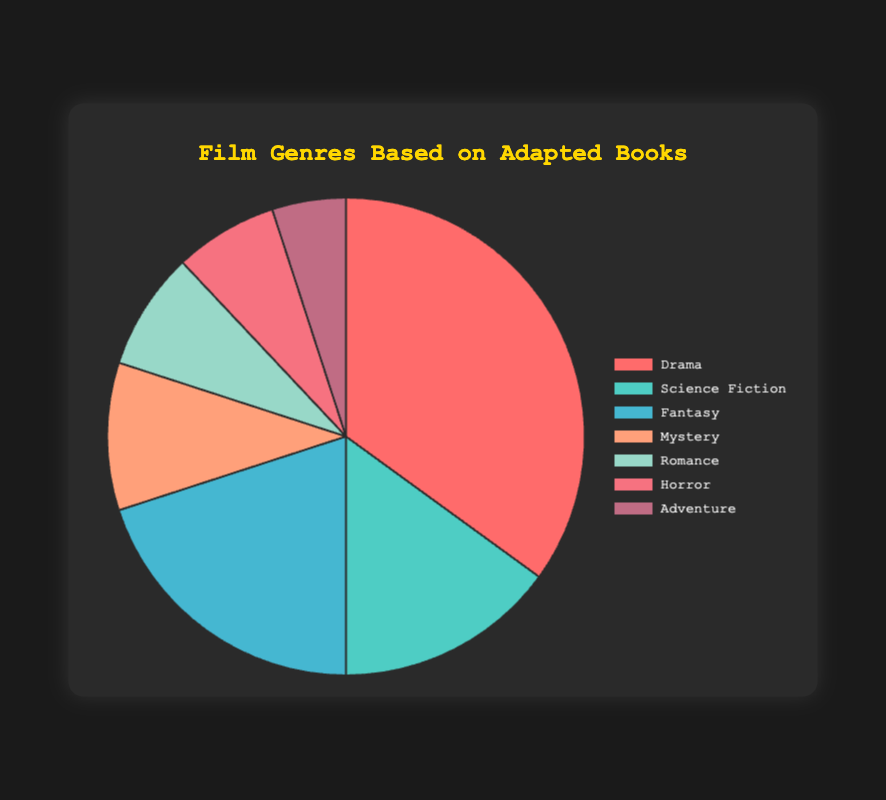What's the most common genre for films based on adapted books? The largest segment of the pie chart represents Drama, which comprises 35% of the films based on adapted books, making it the most common genre.
Answer: Drama Which genre has the least representation in films based on adapted books? The smallest segment of the pie chart represents Adventure, making up 5% of the films based on adapted books, making it the least represented genre.
Answer: Adventure How many genres have a representation of less than 10%? Three genres—Romance (8%), Horror (7%), and Adventure (5%)—each constitute less than 10% of the films based on adapted books.
Answer: 3 What is the combined percentage of Science Fiction and Fantasy genres? The Science Fiction genre is 15% and Fantasy is 20%. Their combined percentage is calculated by summing these: 15% + 20% = 35%.
Answer: 35% Which genre is depicted in red in the pie chart? The pie chart uses red to represent Drama, which comprises 35% of the films based on adapted books.
Answer: Drama What is the difference in percentage between the Romance and Horror genres? Romance accounts for 8% and Horror for 7%. The difference is calculated as 8% - 7% = 1%.
Answer: 1% Which genre has a larger percentage, Mystery or Adventure, and by how much? Mystery has 10%, while Adventure has 5%. Mystery is larger by 10% - 5% = 5%.
Answer: Mystery, 5% What percentage of the films are either Drama or Mystery? Drama accounts for 35%, and Mystery accounts for 10%. Adding these percentages gives 35% + 10% = 45%.
Answer: 45% Which two genres are closest in representation, and what are their percentages? Romance (8%) and Horror (7%) are the two closest in representation, with only a 1% difference between them.
Answer: Romance (8%) and Horror (7%) Among the genres listed, which genre is represented by the color green? Green represents Science Fiction, which comprises 15% of the films based on adapted books.
Answer: Science Fiction 